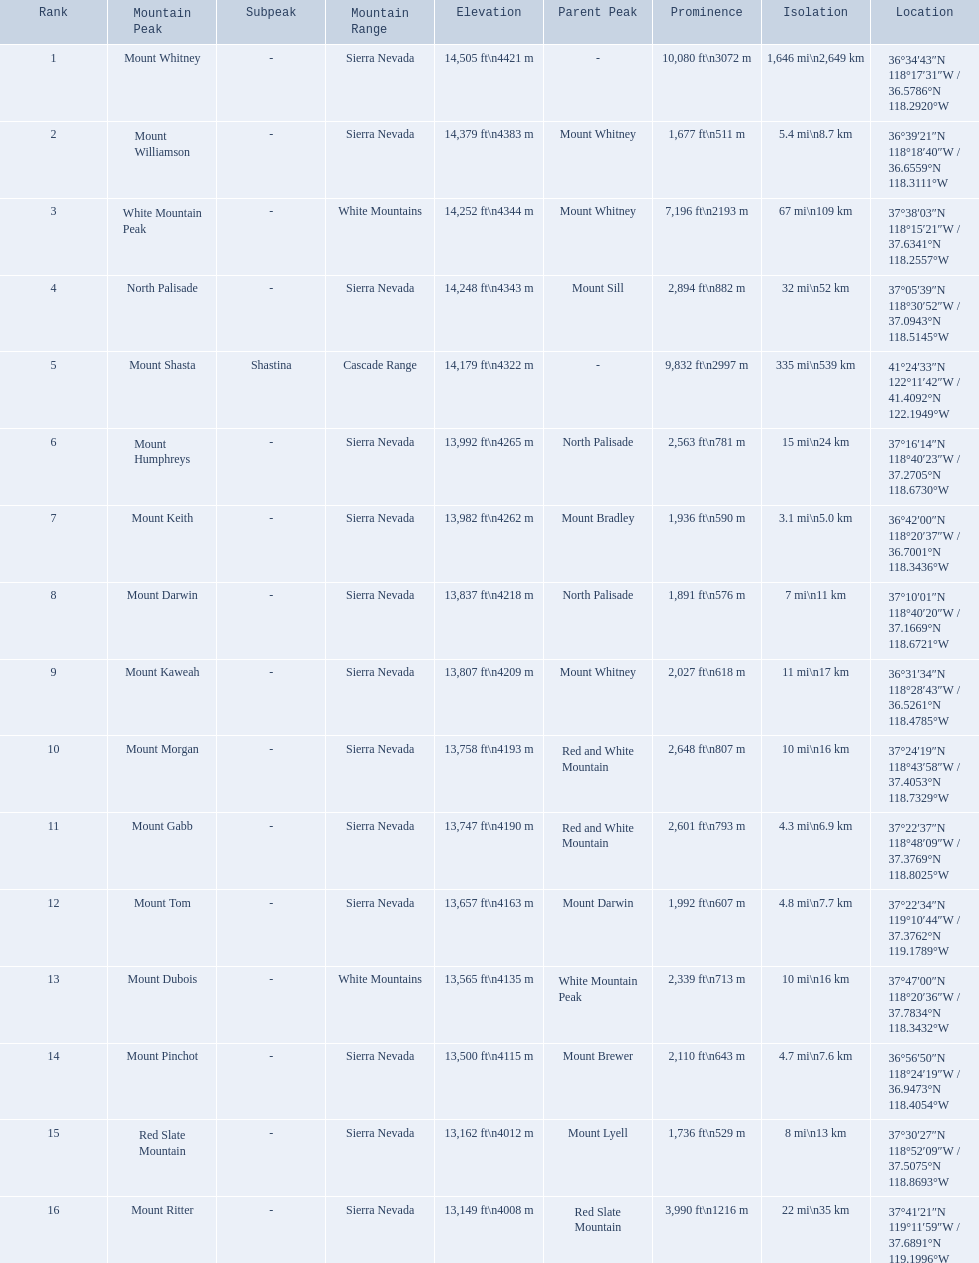What are the peaks in california? Mount Whitney, Mount Williamson, White Mountain Peak, North Palisade, Mount Shasta, Mount Humphreys, Mount Keith, Mount Darwin, Mount Kaweah, Mount Morgan, Mount Gabb, Mount Tom, Mount Dubois, Mount Pinchot, Red Slate Mountain, Mount Ritter. What are the peaks in sierra nevada, california? Mount Whitney, Mount Williamson, North Palisade, Mount Humphreys, Mount Keith, Mount Darwin, Mount Kaweah, Mount Morgan, Mount Gabb, Mount Tom, Mount Pinchot, Red Slate Mountain, Mount Ritter. What are the heights of the peaks in sierra nevada? 14,505 ft\n4421 m, 14,379 ft\n4383 m, 14,248 ft\n4343 m, 13,992 ft\n4265 m, 13,982 ft\n4262 m, 13,837 ft\n4218 m, 13,807 ft\n4209 m, 13,758 ft\n4193 m, 13,747 ft\n4190 m, 13,657 ft\n4163 m, 13,500 ft\n4115 m, 13,162 ft\n4012 m, 13,149 ft\n4008 m. Which is the highest? Mount Whitney. 